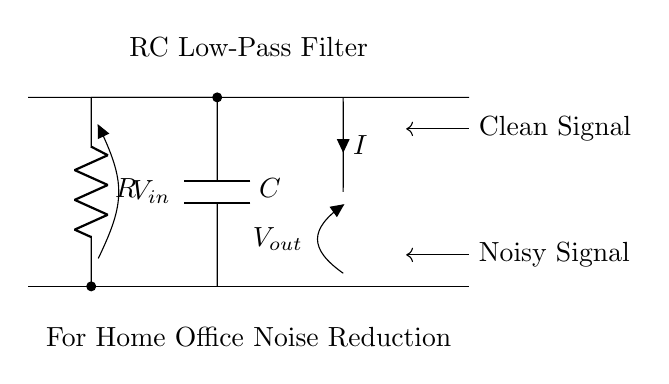What type of filter is represented in this circuit? The circuit diagram shows a low-pass filter, which allows low-frequency signals to pass while attenuating high-frequency signals. This is evident from the arrangement of the resistor and capacitor, which is characteristic of a low-pass filter configuration.
Answer: Low-pass filter What component is labeled with the letter C? The letter C corresponds to the capacitor in the circuit diagram, which is used to store electrical energy temporarily and is an essential part of the filter.
Answer: Capacitor What is the function of the resistor in this circuit? The resistor limits the amount of current flowing through the circuit and affects the charging and discharging rates of the capacitor, thus playing a crucial role in determining the filter's cutoff frequency.
Answer: Limit current What is the role of Vout in this circuit? Vout represents the output voltage across the capacitor, indicating the filtered signal that is expected to have reduced noise compared to the input signal.
Answer: Filtered signal What do the arrows marked as 'Clean Signal' and 'Noisy Signal' indicate? The arrows indicate the input and output signals of the circuit: the 'Noisy Signal' is the input to the RC filter, while the 'Clean Signal' represents the output after filtering, which should have less noise.
Answer: Input and output signals How does the RC value affect the filtering characteristics? The resistance R and capacitance C determine the cutoff frequency of the filter according to the formula 1/(2πRC), impacting how well the filter attenuates higher frequencies and allowing certain frequency signals to pass.
Answer: Cutoff frequency What happens to higher frequency signals in this RC filter? Higher frequency signals are attenuated or reduced in amplitude as they pass through the filter, due to the reactive nature of the capacitor and the resistive element, which impedes their flow.
Answer: Attenuated 